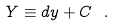Convert formula to latex. <formula><loc_0><loc_0><loc_500><loc_500>Y \equiv d y + C \ .</formula> 